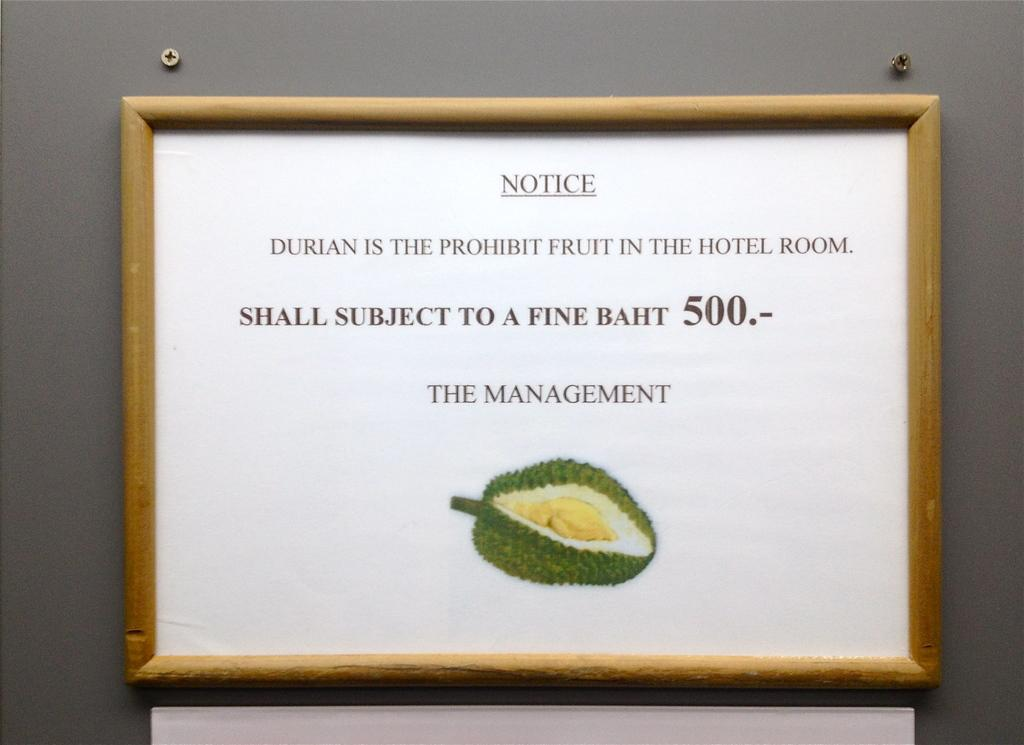<image>
Render a clear and concise summary of the photo. A sign that says notice and is from the management. 